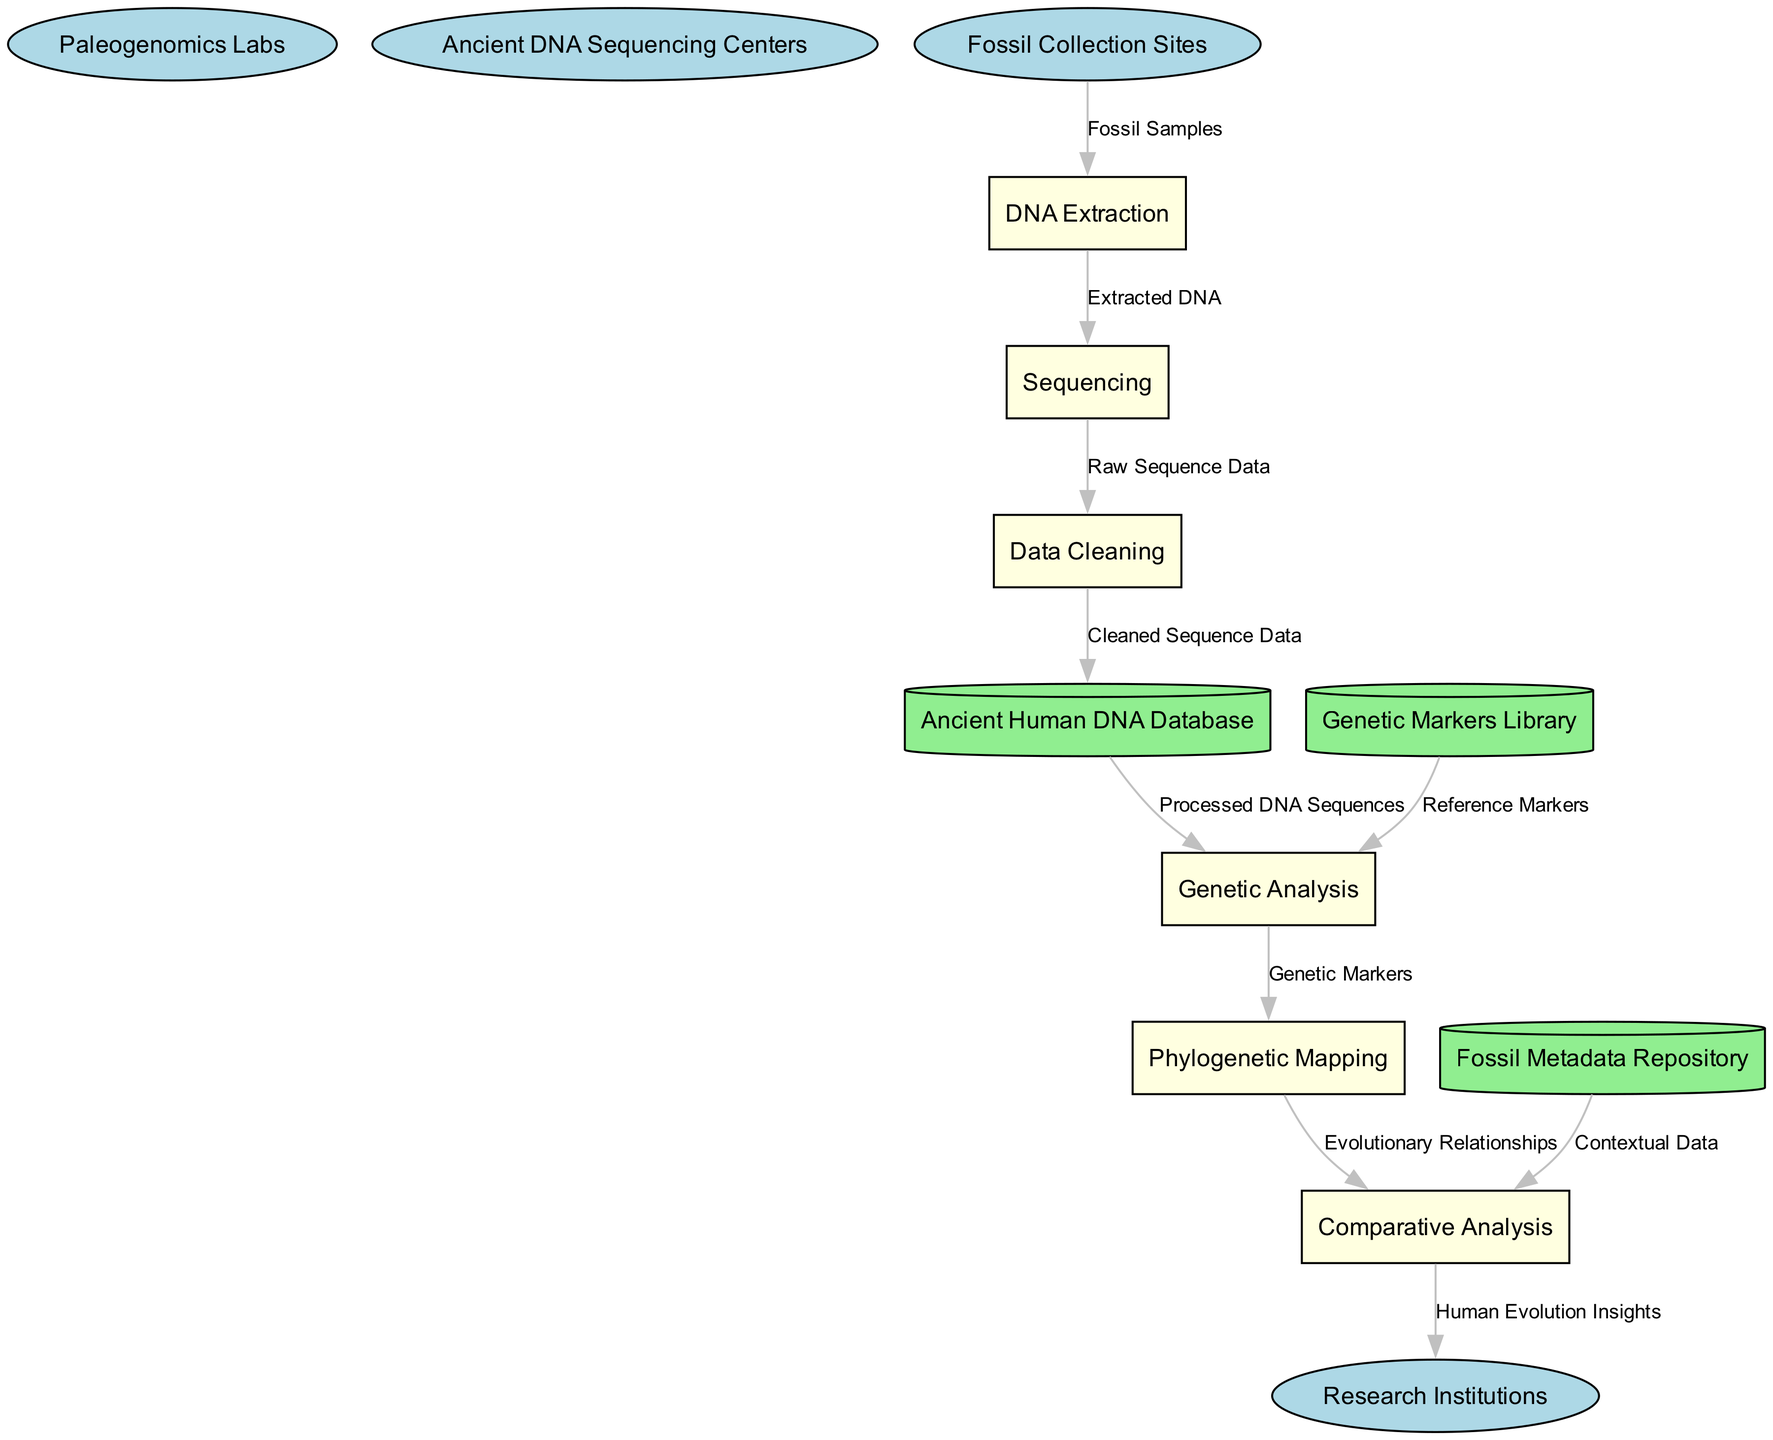What are the external entities in the diagram? The external entities include "Paleogenomics Labs," "Ancient DNA Sequencing Centers," "Fossil Collection Sites," and "Research Institutions." These are represented as ellipses in the diagram.
Answer: Paleogenomics Labs, Ancient DNA Sequencing Centers, Fossil Collection Sites, Research Institutions How many processes are there in total? Counting from the listed processes, there are six processes: "DNA Extraction," "Sequencing," "Data Cleaning," "Genetic Analysis," "Phylogenetic Mapping," and "Comparative Analysis."
Answer: 6 What type of data flows from "Fossil Collection Sites" to "DNA Extraction"? The flow from "Fossil Collection Sites" to "DNA Extraction" is labeled as "Fossil Samples." This indicates the type of data being transferred between these nodes.
Answer: Fossil Samples Which process receives "Cleaned Sequence Data"? The process that receives "Cleaned Sequence Data" is "Ancient Human DNA Database." This is the immediate destination in the data flow following "Data Cleaning."
Answer: Ancient Human DNA Database What is the final output of the entire process flow? The final output of the process flow is "Human Evolution Insights." This is the last flow leading from "Comparative Analysis" to "Research Institutions."
Answer: Human Evolution Insights Which data store provides "Contextual Data" for the analysis? The "Fossil Metadata Repository" provides "Contextual Data," which flows into the "Comparative Analysis" process, supporting its operations with background information.
Answer: Fossil Metadata Repository What type of data is transferred from "Genetic Markers Library" to "Genetic Analysis"? The data transferred is labeled as "Reference Markers," which are essential for the analysis of the genetic sequences processed earlier.
Answer: Reference Markers How many data stores are represented in the diagram? There are three data stores in the diagram: "Ancient Human DNA Database," "Fossil Metadata Repository," and "Genetic Markers Library." Each is represented using a cylindrical shape.
Answer: 3 What is the relationship between "Phylogenetic Mapping" and "Comparative Analysis"? The relationship is that "Phylogenetic Mapping" sends "Evolutionary Relationships" to "Comparative Analysis," indicating a flow of information crucial for understanding the results of the mapping in a comparative context.
Answer: Evolutionary Relationships 